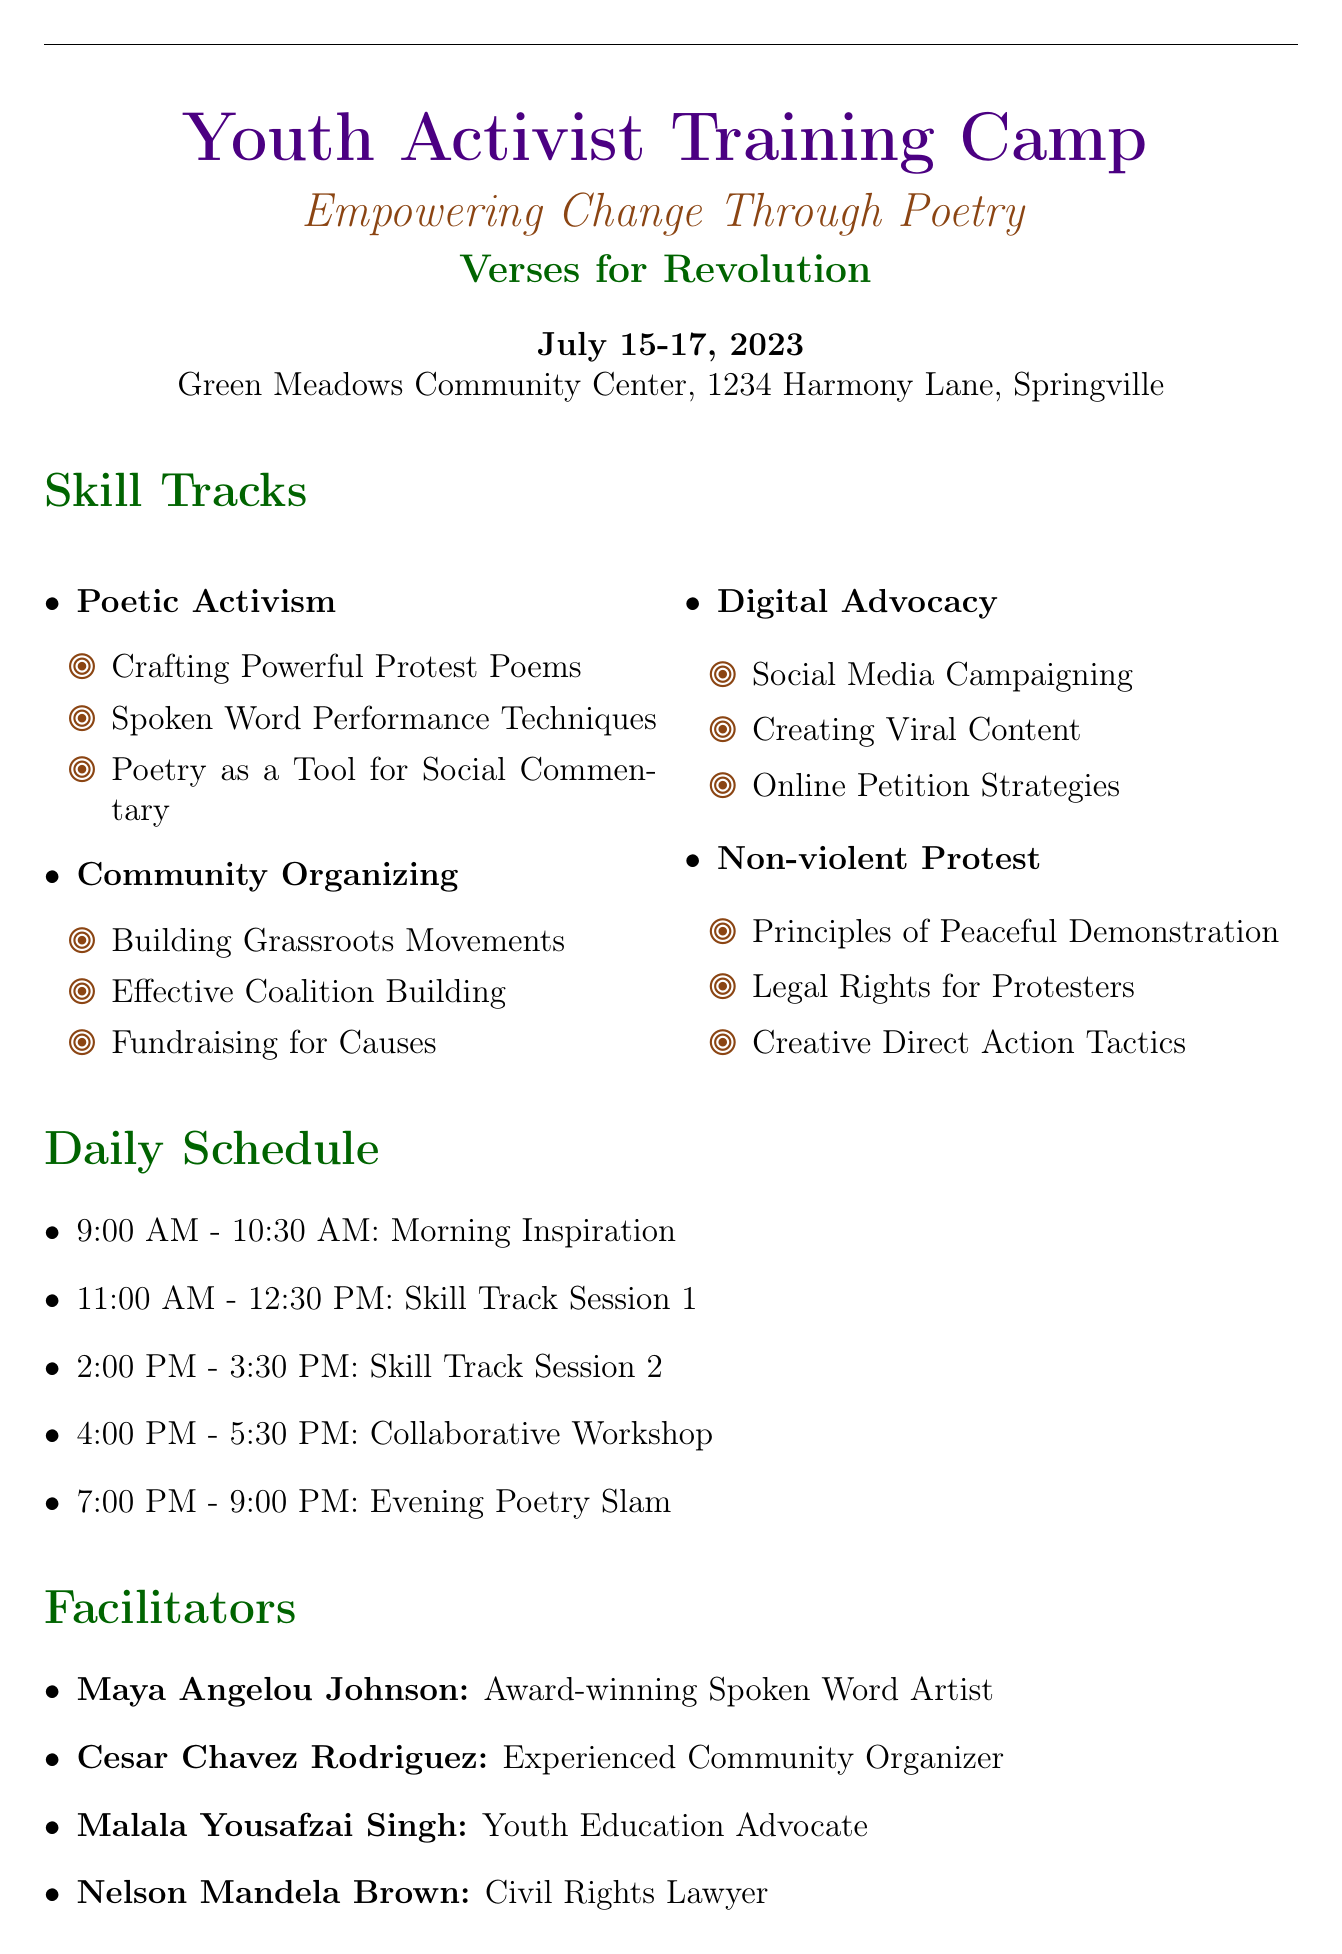What is the title of the workshop? The title of the workshop is the main heading found at the top of the document.
Answer: Youth Activist Training Camp: Empowering Change Through Poetry What are the dates of the training camp? The dates are listed as the timeframe during which the workshop will occur.
Answer: July 15-17, 2023 Who is the organization hosting the event? The organization name is mentioned under the title as the entity responsible for the workshop.
Answer: Verses for Revolution Which session is scheduled for the morning inspiration time slot? The morning inspiration session is indicated by the morning time block within the general schedule.
Answer: Morning Inspiration What is the registration deadline? The deadline is the last date one can register for the workshop, stated in the registration information section.
Answer: July 1, 2023 How much is the registration fee for the workshop? The fee is explicitly mentioned in the registration information section of the document.
Answer: $50 What track includes "Social Media Campaigning"? This track is part of the skill tracks section and includes sessions related to digital advocacy.
Answer: Digital Advocacy Who is facilitating a session on "Building Grassroots Movements"? The facilitator's name is specified under facilitators and corresponds to the community organizing track.
Answer: Cesar Chavez Rodriguez What accessibility feature is available upon request? Several accessibility features are listed, with one specifically noted as available upon request.
Answer: Sign language interpreters 